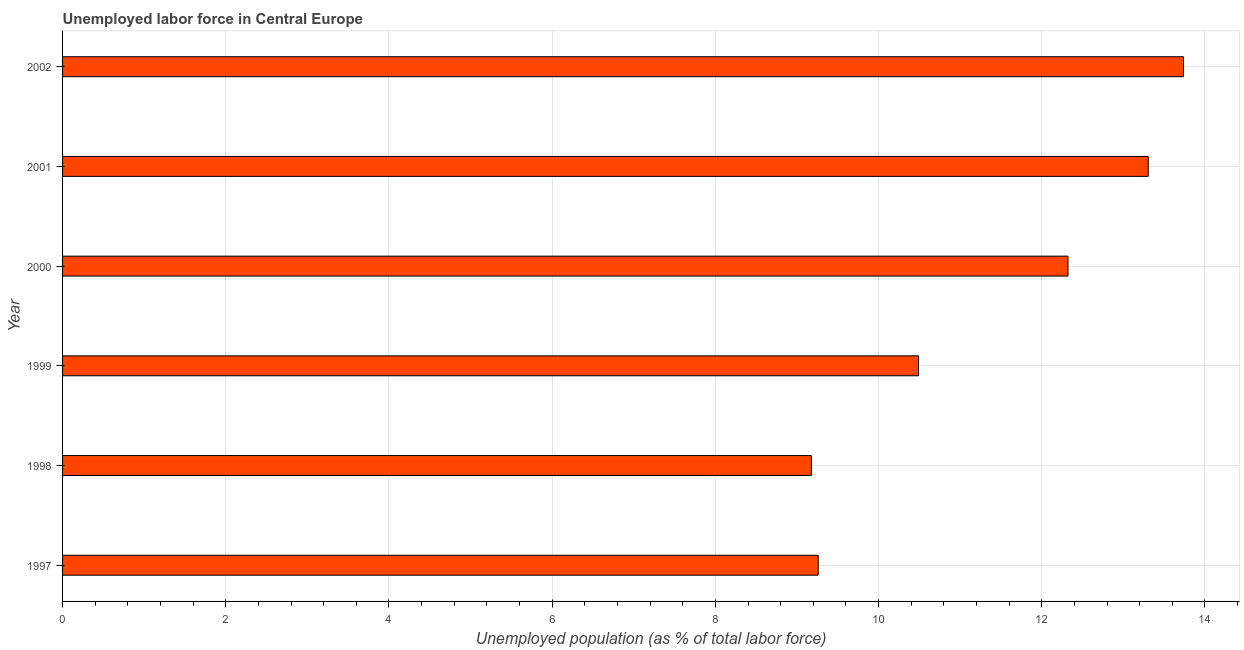Does the graph contain grids?
Offer a terse response. Yes. What is the title of the graph?
Make the answer very short. Unemployed labor force in Central Europe. What is the label or title of the X-axis?
Give a very brief answer. Unemployed population (as % of total labor force). What is the label or title of the Y-axis?
Ensure brevity in your answer.  Year. What is the total unemployed population in 2001?
Your answer should be compact. 13.3. Across all years, what is the maximum total unemployed population?
Your answer should be very brief. 13.74. Across all years, what is the minimum total unemployed population?
Give a very brief answer. 9.18. In which year was the total unemployed population maximum?
Provide a short and direct response. 2002. In which year was the total unemployed population minimum?
Ensure brevity in your answer.  1998. What is the sum of the total unemployed population?
Your answer should be compact. 68.29. What is the difference between the total unemployed population in 2000 and 2002?
Your response must be concise. -1.42. What is the average total unemployed population per year?
Give a very brief answer. 11.38. What is the median total unemployed population?
Ensure brevity in your answer.  11.41. In how many years, is the total unemployed population greater than 8 %?
Your answer should be compact. 6. Do a majority of the years between 1998 and 2000 (inclusive) have total unemployed population greater than 2.4 %?
Ensure brevity in your answer.  Yes. What is the ratio of the total unemployed population in 1997 to that in 1999?
Offer a very short reply. 0.88. Is the total unemployed population in 1997 less than that in 2001?
Ensure brevity in your answer.  Yes. What is the difference between the highest and the second highest total unemployed population?
Provide a short and direct response. 0.43. What is the difference between the highest and the lowest total unemployed population?
Give a very brief answer. 4.56. Are all the bars in the graph horizontal?
Your answer should be compact. Yes. How many years are there in the graph?
Your answer should be compact. 6. What is the Unemployed population (as % of total labor force) in 1997?
Your answer should be very brief. 9.26. What is the Unemployed population (as % of total labor force) in 1998?
Provide a short and direct response. 9.18. What is the Unemployed population (as % of total labor force) of 1999?
Your answer should be compact. 10.49. What is the Unemployed population (as % of total labor force) of 2000?
Provide a short and direct response. 12.32. What is the Unemployed population (as % of total labor force) of 2001?
Your answer should be very brief. 13.3. What is the Unemployed population (as % of total labor force) in 2002?
Give a very brief answer. 13.74. What is the difference between the Unemployed population (as % of total labor force) in 1997 and 1998?
Your response must be concise. 0.08. What is the difference between the Unemployed population (as % of total labor force) in 1997 and 1999?
Offer a terse response. -1.23. What is the difference between the Unemployed population (as % of total labor force) in 1997 and 2000?
Your response must be concise. -3.06. What is the difference between the Unemployed population (as % of total labor force) in 1997 and 2001?
Offer a very short reply. -4.04. What is the difference between the Unemployed population (as % of total labor force) in 1997 and 2002?
Your answer should be compact. -4.48. What is the difference between the Unemployed population (as % of total labor force) in 1998 and 1999?
Provide a succinct answer. -1.31. What is the difference between the Unemployed population (as % of total labor force) in 1998 and 2000?
Give a very brief answer. -3.15. What is the difference between the Unemployed population (as % of total labor force) in 1998 and 2001?
Make the answer very short. -4.13. What is the difference between the Unemployed population (as % of total labor force) in 1998 and 2002?
Offer a terse response. -4.56. What is the difference between the Unemployed population (as % of total labor force) in 1999 and 2000?
Provide a short and direct response. -1.83. What is the difference between the Unemployed population (as % of total labor force) in 1999 and 2001?
Offer a terse response. -2.81. What is the difference between the Unemployed population (as % of total labor force) in 1999 and 2002?
Provide a succinct answer. -3.25. What is the difference between the Unemployed population (as % of total labor force) in 2000 and 2001?
Your answer should be very brief. -0.98. What is the difference between the Unemployed population (as % of total labor force) in 2000 and 2002?
Make the answer very short. -1.41. What is the difference between the Unemployed population (as % of total labor force) in 2001 and 2002?
Your response must be concise. -0.43. What is the ratio of the Unemployed population (as % of total labor force) in 1997 to that in 1999?
Keep it short and to the point. 0.88. What is the ratio of the Unemployed population (as % of total labor force) in 1997 to that in 2000?
Give a very brief answer. 0.75. What is the ratio of the Unemployed population (as % of total labor force) in 1997 to that in 2001?
Ensure brevity in your answer.  0.7. What is the ratio of the Unemployed population (as % of total labor force) in 1997 to that in 2002?
Ensure brevity in your answer.  0.67. What is the ratio of the Unemployed population (as % of total labor force) in 1998 to that in 1999?
Offer a very short reply. 0.88. What is the ratio of the Unemployed population (as % of total labor force) in 1998 to that in 2000?
Make the answer very short. 0.74. What is the ratio of the Unemployed population (as % of total labor force) in 1998 to that in 2001?
Your answer should be very brief. 0.69. What is the ratio of the Unemployed population (as % of total labor force) in 1998 to that in 2002?
Your response must be concise. 0.67. What is the ratio of the Unemployed population (as % of total labor force) in 1999 to that in 2000?
Make the answer very short. 0.85. What is the ratio of the Unemployed population (as % of total labor force) in 1999 to that in 2001?
Ensure brevity in your answer.  0.79. What is the ratio of the Unemployed population (as % of total labor force) in 1999 to that in 2002?
Offer a terse response. 0.76. What is the ratio of the Unemployed population (as % of total labor force) in 2000 to that in 2001?
Give a very brief answer. 0.93. What is the ratio of the Unemployed population (as % of total labor force) in 2000 to that in 2002?
Your response must be concise. 0.9. What is the ratio of the Unemployed population (as % of total labor force) in 2001 to that in 2002?
Your answer should be very brief. 0.97. 